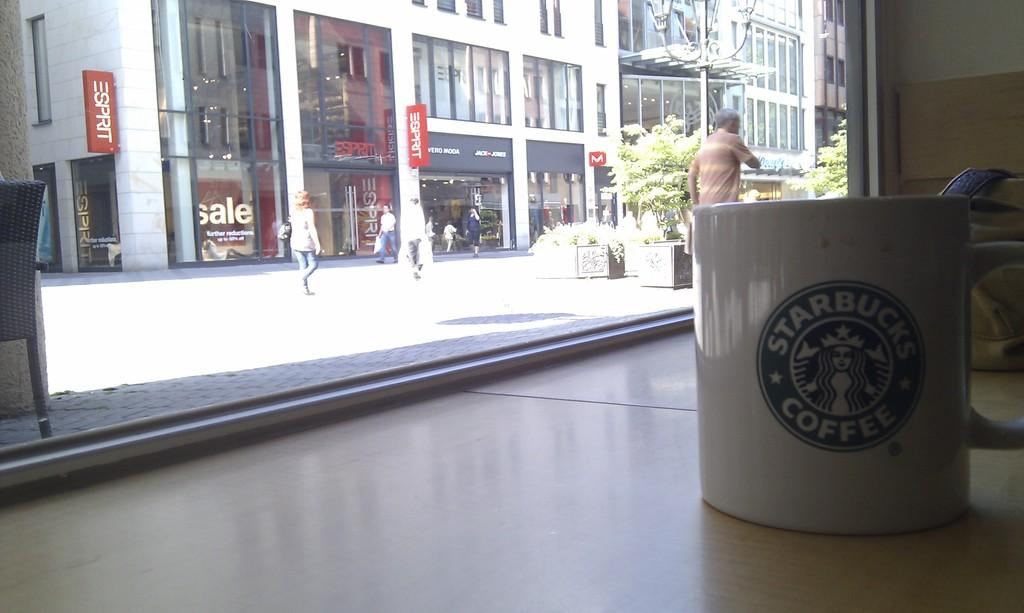<image>
Present a compact description of the photo's key features. White cup with a starbucks coffee logo in green and white. 